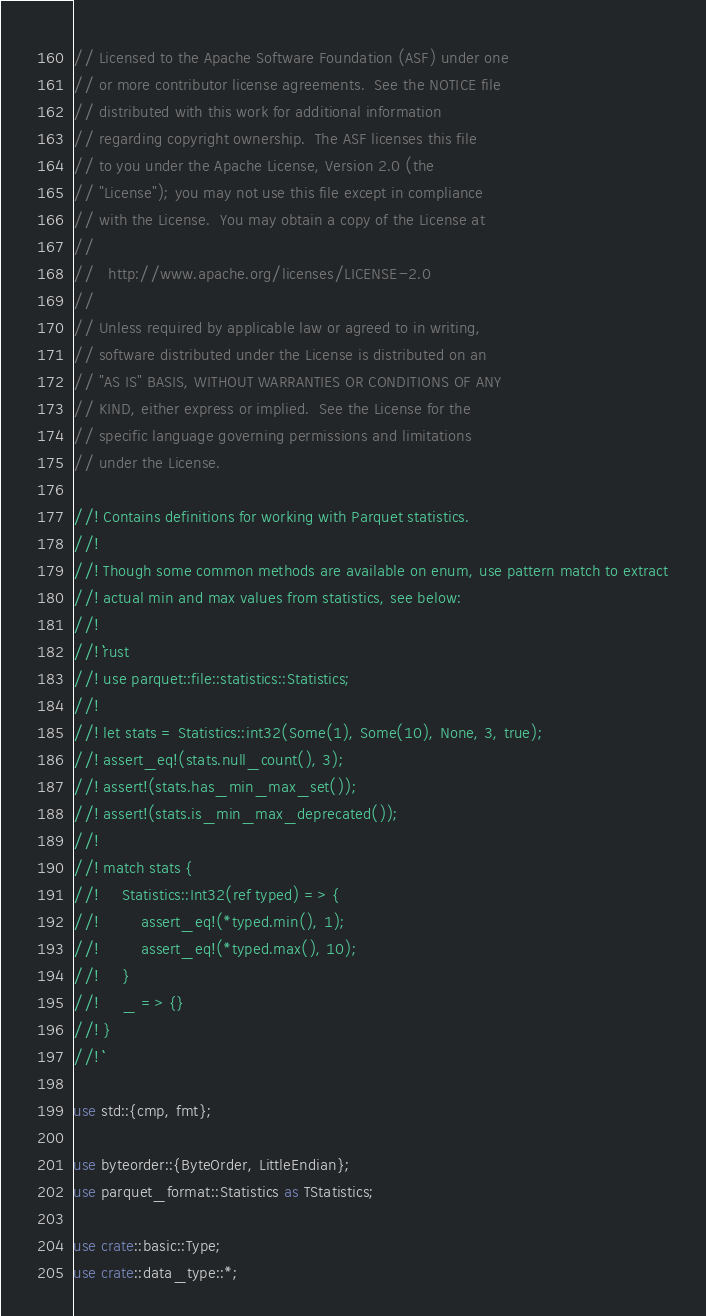<code> <loc_0><loc_0><loc_500><loc_500><_Rust_>// Licensed to the Apache Software Foundation (ASF) under one
// or more contributor license agreements.  See the NOTICE file
// distributed with this work for additional information
// regarding copyright ownership.  The ASF licenses this file
// to you under the Apache License, Version 2.0 (the
// "License"); you may not use this file except in compliance
// with the License.  You may obtain a copy of the License at
//
//   http://www.apache.org/licenses/LICENSE-2.0
//
// Unless required by applicable law or agreed to in writing,
// software distributed under the License is distributed on an
// "AS IS" BASIS, WITHOUT WARRANTIES OR CONDITIONS OF ANY
// KIND, either express or implied.  See the License for the
// specific language governing permissions and limitations
// under the License.

//! Contains definitions for working with Parquet statistics.
//!
//! Though some common methods are available on enum, use pattern match to extract
//! actual min and max values from statistics, see below:
//!
//! ```rust
//! use parquet::file::statistics::Statistics;
//!
//! let stats = Statistics::int32(Some(1), Some(10), None, 3, true);
//! assert_eq!(stats.null_count(), 3);
//! assert!(stats.has_min_max_set());
//! assert!(stats.is_min_max_deprecated());
//!
//! match stats {
//!     Statistics::Int32(ref typed) => {
//!         assert_eq!(*typed.min(), 1);
//!         assert_eq!(*typed.max(), 10);
//!     }
//!     _ => {}
//! }
//! ```

use std::{cmp, fmt};

use byteorder::{ByteOrder, LittleEndian};
use parquet_format::Statistics as TStatistics;

use crate::basic::Type;
use crate::data_type::*;
</code> 